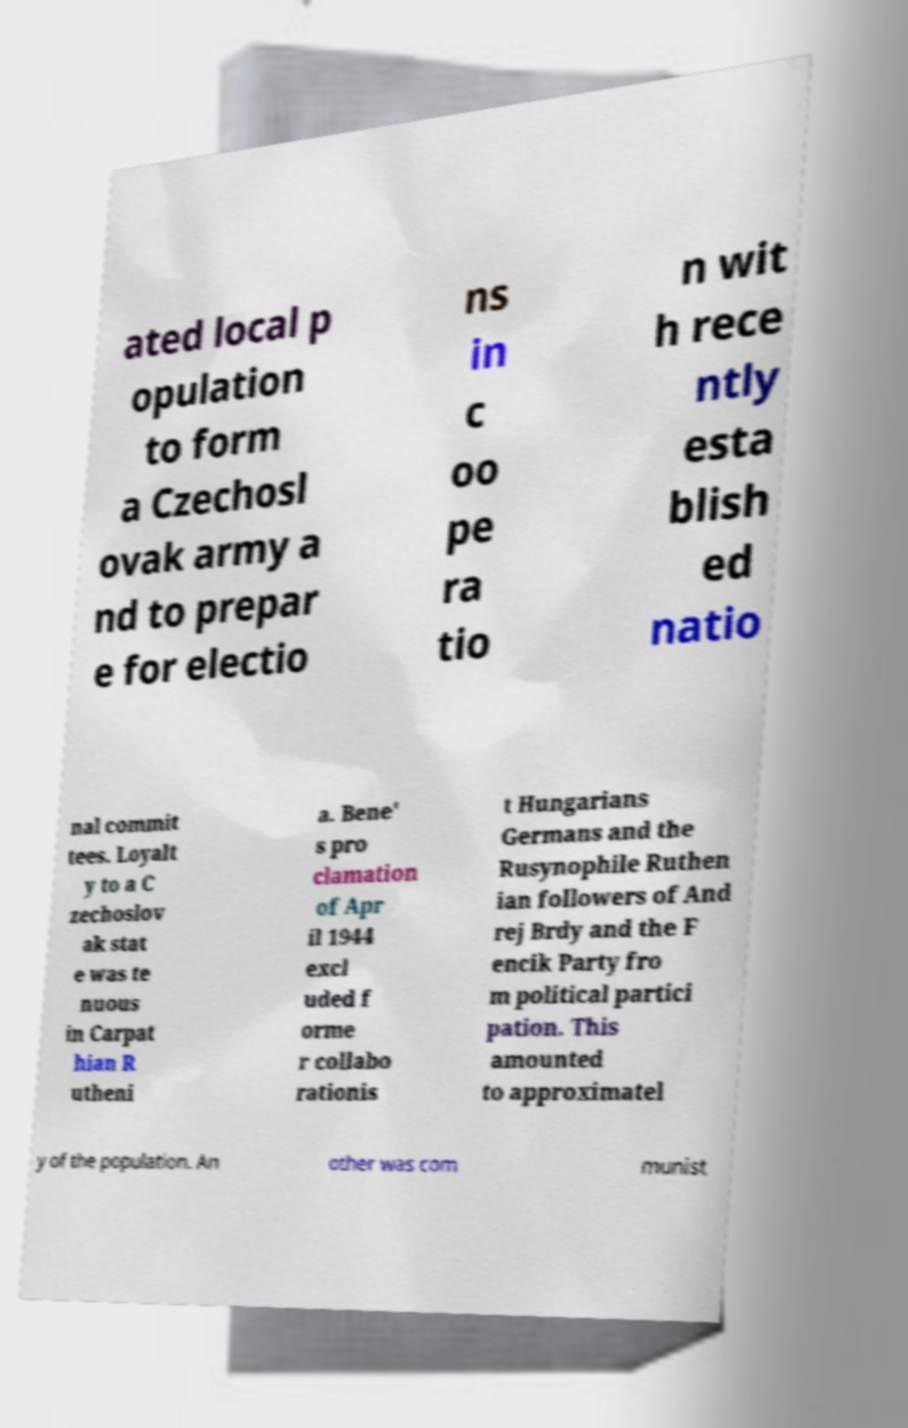Could you assist in decoding the text presented in this image and type it out clearly? ated local p opulation to form a Czechosl ovak army a nd to prepar e for electio ns in c oo pe ra tio n wit h rece ntly esta blish ed natio nal commit tees. Loyalt y to a C zechoslov ak stat e was te nuous in Carpat hian R utheni a. Bene' s pro clamation of Apr il 1944 excl uded f orme r collabo rationis t Hungarians Germans and the Rusynophile Ruthen ian followers of And rej Brdy and the F encik Party fro m political partici pation. This amounted to approximatel y of the population. An other was com munist 